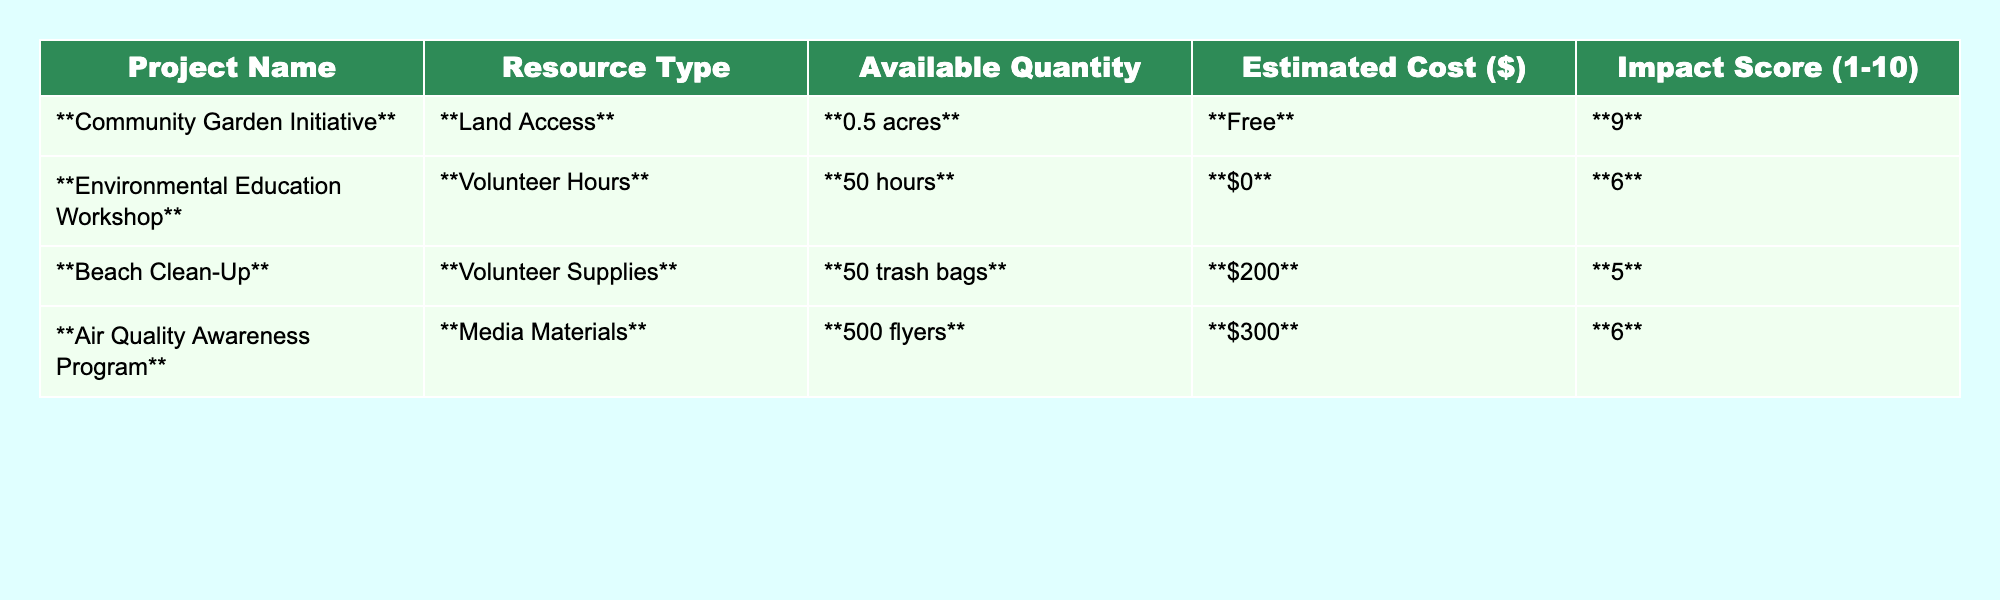What is the impact score of the Beach Clean-Up project? The impact score for the Beach Clean-Up project is listed in the table as 5.
Answer: 5 Which project has the highest available resource quantity? Community Garden Initiative has the highest available resource quantity of 0.5 acres.
Answer: 0.5 acres What is the estimated cost of the Air Quality Awareness Program? The estimated cost for the Air Quality Awareness Program is $300, as indicated in the table.
Answer: $300 Is the estimated cost of the Environmental Education Workshop free? Yes, the estimated cost for the Environmental Education Workshop is stated as $0, which means it is free.
Answer: Yes Which projects have an impact score of 6 or higher? The Community Garden Initiative (9) and the Environmental Education Workshop (6) both have an impact score of 6 or higher.
Answer: Community Garden Initiative, Environmental Education Workshop What is the total estimated cost of the volunteer-based projects? The volunteer-based projects are Environmental Education Workshop ($0) and Beach Clean-Up ($200). The total estimated cost is $0 + $200 = $200.
Answer: $200 How much volunteer time is available across all listed projects? The only project that has volunteer time listed is the Environmental Education Workshop with 50 hours available. Hence, the total is 50 hours.
Answer: 50 hours Which project has the lowest impact score, and what is that score? The Beach Clean-Up project has the lowest impact score, which is 5.
Answer: 5 What percentage of the total resources (measured in impact scores) come from projects with volunteer hours? The total impact scores are 9 + 6 + 5 + 6 = 26. The only project with volunteer hours is the Environmental Education Workshop contributing 6. Hence, the percentage is (6/26) * 100 = 23.08%.
Answer: 23.08% If we combine the impact scores of all projects, what is the result? The combined impact scores are 9 (Community Garden Initiative) + 6 (Environmental Education Workshop) + 5 (Beach Clean-Up) + 6 (Air Quality Awareness Program) = 26.
Answer: 26 